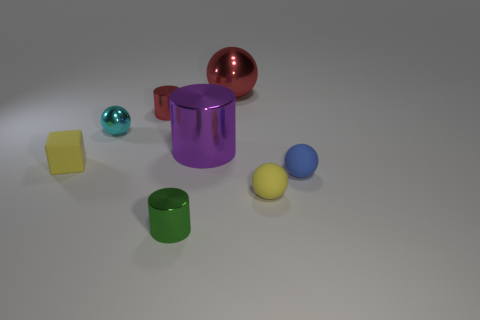What number of things are either spheres on the right side of the cyan object or tiny metal cylinders in front of the blue matte ball?
Provide a succinct answer. 4. How many objects are either green metallic objects or cyan metallic objects?
Ensure brevity in your answer.  2. There is a metallic ball that is on the left side of the red metallic ball; how many blue things are behind it?
Keep it short and to the point. 0. What number of other things are the same size as the blue matte object?
Keep it short and to the point. 5. What is the size of the ball that is the same color as the tiny block?
Offer a terse response. Small. Does the yellow matte thing to the right of the tiny red thing have the same shape as the tiny green object?
Keep it short and to the point. No. What material is the ball behind the red metal cylinder?
Ensure brevity in your answer.  Metal. What shape is the metal object that is the same color as the large metallic sphere?
Make the answer very short. Cylinder. Is there a tiny yellow sphere that has the same material as the big purple thing?
Offer a very short reply. No. What size is the green thing?
Provide a short and direct response. Small. 